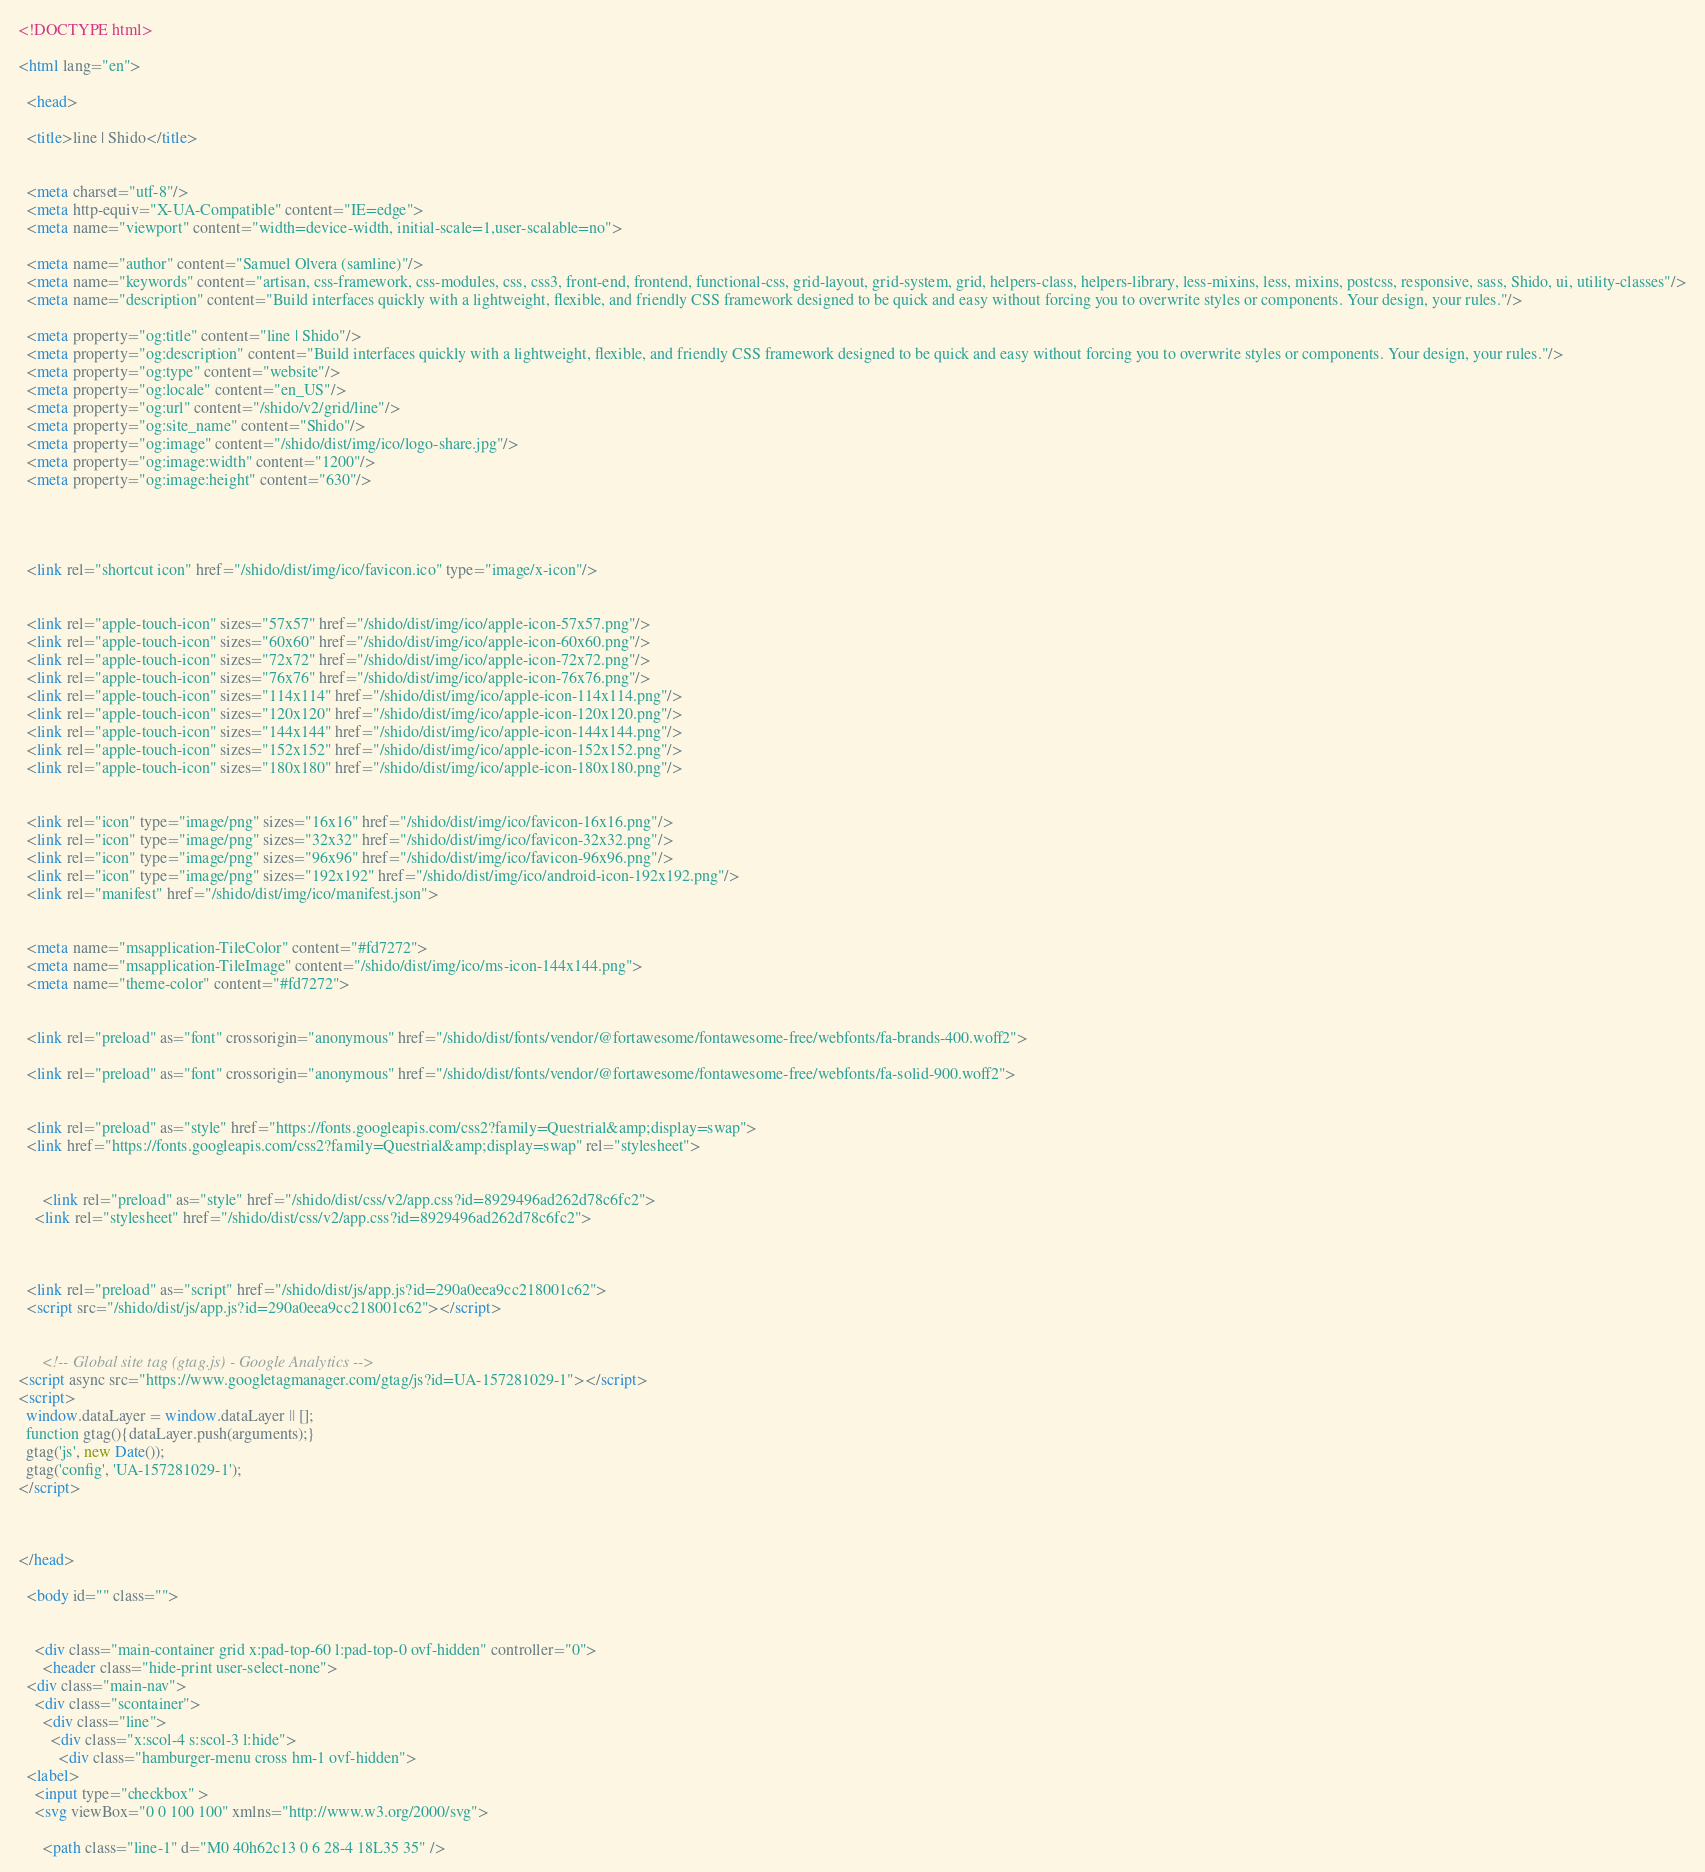Convert code to text. <code><loc_0><loc_0><loc_500><loc_500><_HTML_><!DOCTYPE html>

<html lang="en">

  <head>

  <title>line | Shido</title>

  
  <meta charset="utf-8"/>
  <meta http-equiv="X-UA-Compatible" content="IE=edge">
  <meta name="viewport" content="width=device-width, initial-scale=1,user-scalable=no">

  <meta name="author" content="Samuel Olvera (samline)"/>
  <meta name="keywords" content="artisan, css-framework, css-modules, css, css3, front-end, frontend, functional-css, grid-layout, grid-system, grid, helpers-class, helpers-library, less-mixins, less, mixins, postcss, responsive, sass, Shido, ui, utility-classes"/>
  <meta name="description" content="Build interfaces quickly with a lightweight, flexible, and friendly CSS framework designed to be quick and easy without forcing you to overwrite styles or components. Your design, your rules."/>

  <meta property="og:title" content="line | Shido"/>
  <meta property="og:description" content="Build interfaces quickly with a lightweight, flexible, and friendly CSS framework designed to be quick and easy without forcing you to overwrite styles or components. Your design, your rules."/>
  <meta property="og:type" content="website"/>
  <meta property="og:locale" content="en_US"/>
  <meta property="og:url" content="/shido/v2/grid/line"/>
  <meta property="og:site_name" content="Shido"/>
  <meta property="og:image" content="/shido/dist/img/ico/logo-share.jpg"/>
  <meta property="og:image:width" content="1200"/>
  <meta property="og:image:height" content="630"/>

  
  
  
  <link rel="shortcut icon" href="/shido/dist/img/ico/favicon.ico" type="image/x-icon"/>

  
  <link rel="apple-touch-icon" sizes="57x57" href="/shido/dist/img/ico/apple-icon-57x57.png"/>
  <link rel="apple-touch-icon" sizes="60x60" href="/shido/dist/img/ico/apple-icon-60x60.png"/>
  <link rel="apple-touch-icon" sizes="72x72" href="/shido/dist/img/ico/apple-icon-72x72.png"/>
  <link rel="apple-touch-icon" sizes="76x76" href="/shido/dist/img/ico/apple-icon-76x76.png"/>
  <link rel="apple-touch-icon" sizes="114x114" href="/shido/dist/img/ico/apple-icon-114x114.png"/>
  <link rel="apple-touch-icon" sizes="120x120" href="/shido/dist/img/ico/apple-icon-120x120.png"/>
  <link rel="apple-touch-icon" sizes="144x144" href="/shido/dist/img/ico/apple-icon-144x144.png"/>
  <link rel="apple-touch-icon" sizes="152x152" href="/shido/dist/img/ico/apple-icon-152x152.png"/>
  <link rel="apple-touch-icon" sizes="180x180" href="/shido/dist/img/ico/apple-icon-180x180.png"/>

  
  <link rel="icon" type="image/png" sizes="16x16" href="/shido/dist/img/ico/favicon-16x16.png"/>
  <link rel="icon" type="image/png" sizes="32x32" href="/shido/dist/img/ico/favicon-32x32.png"/>
  <link rel="icon" type="image/png" sizes="96x96" href="/shido/dist/img/ico/favicon-96x96.png"/>
  <link rel="icon" type="image/png" sizes="192x192" href="/shido/dist/img/ico/android-icon-192x192.png"/>
  <link rel="manifest" href="/shido/dist/img/ico/manifest.json">

  
  <meta name="msapplication-TileColor" content="#fd7272">
  <meta name="msapplication-TileImage" content="/shido/dist/img/ico/ms-icon-144x144.png">
  <meta name="theme-color" content="#fd7272">

  
  <link rel="preload" as="font" crossorigin="anonymous" href="/shido/dist/fonts/vendor/@fortawesome/fontawesome-free/webfonts/fa-brands-400.woff2">
  
  <link rel="preload" as="font" crossorigin="anonymous" href="/shido/dist/fonts/vendor/@fortawesome/fontawesome-free/webfonts/fa-solid-900.woff2">

  
  <link rel="preload" as="style" href="https://fonts.googleapis.com/css2?family=Questrial&amp;display=swap">
  <link href="https://fonts.googleapis.com/css2?family=Questrial&amp;display=swap" rel="stylesheet">

  
      <link rel="preload" as="style" href="/shido/dist/css/v2/app.css?id=8929496ad262d78c6fc2">
    <link rel="stylesheet" href="/shido/dist/css/v2/app.css?id=8929496ad262d78c6fc2">
  
  
  
  <link rel="preload" as="script" href="/shido/dist/js/app.js?id=290a0eea9cc218001c62">
  <script src="/shido/dist/js/app.js?id=290a0eea9cc218001c62"></script>

  
      <!-- Global site tag (gtag.js) - Google Analytics -->
<script async src="https://www.googletagmanager.com/gtag/js?id=UA-157281029-1"></script>
<script>
  window.dataLayer = window.dataLayer || [];
  function gtag(){dataLayer.push(arguments);}
  gtag('js', new Date());
  gtag('config', 'UA-157281029-1');
</script>
              
  
  
</head>

  <body id="" class="">

              
    <div class="main-container grid x:pad-top-60 l:pad-top-0 ovf-hidden" controller="0">
      <header class="hide-print user-select-none">
  <div class="main-nav">
    <div class="scontainer">
      <div class="line">
        <div class="x:scol-4 s:scol-3 l:hide">
          <div class="hamburger-menu cross hm-1 ovf-hidden">
  <label>
    <input type="checkbox" >
    <svg viewBox="0 0 100 100" xmlns="http://www.w3.org/2000/svg">
      
      <path class="line-1" d="M0 40h62c13 0 6 28-4 18L35 35" /></code> 